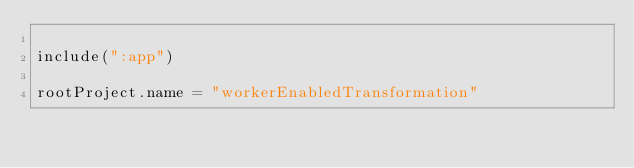Convert code to text. <code><loc_0><loc_0><loc_500><loc_500><_Kotlin_>
include(":app")

rootProject.name = "workerEnabledTransformation"
</code> 